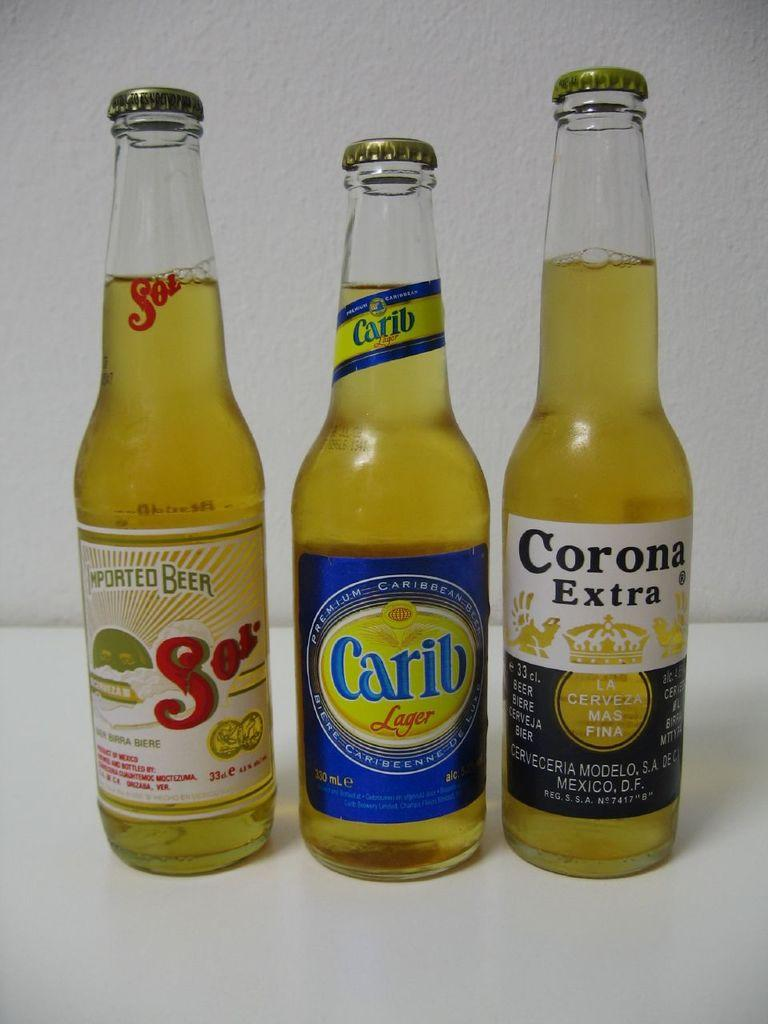<image>
Present a compact description of the photo's key features. A bottle of Corona Extra next to two other bottles. 